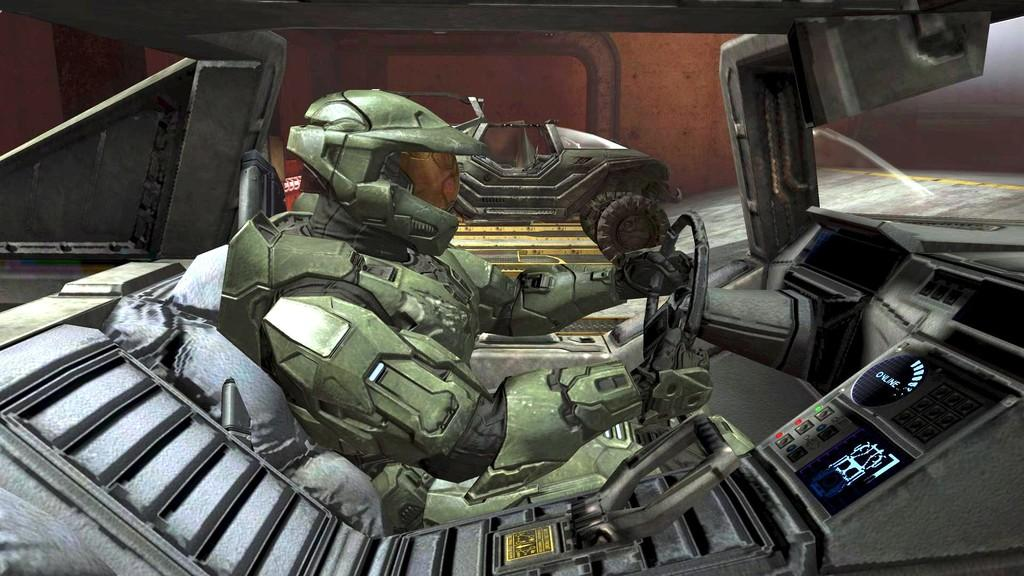What type of image is this? The image appears to be animated. What is happening in the image? There is a person-like thing driving a vehicle in the image. What else can be seen in the background of the image? There are other items visible in the background of the image. What type of faucet can be seen in the image? There is no faucet present in the image. What color is the brass in the image? There is no brass present in the image. 